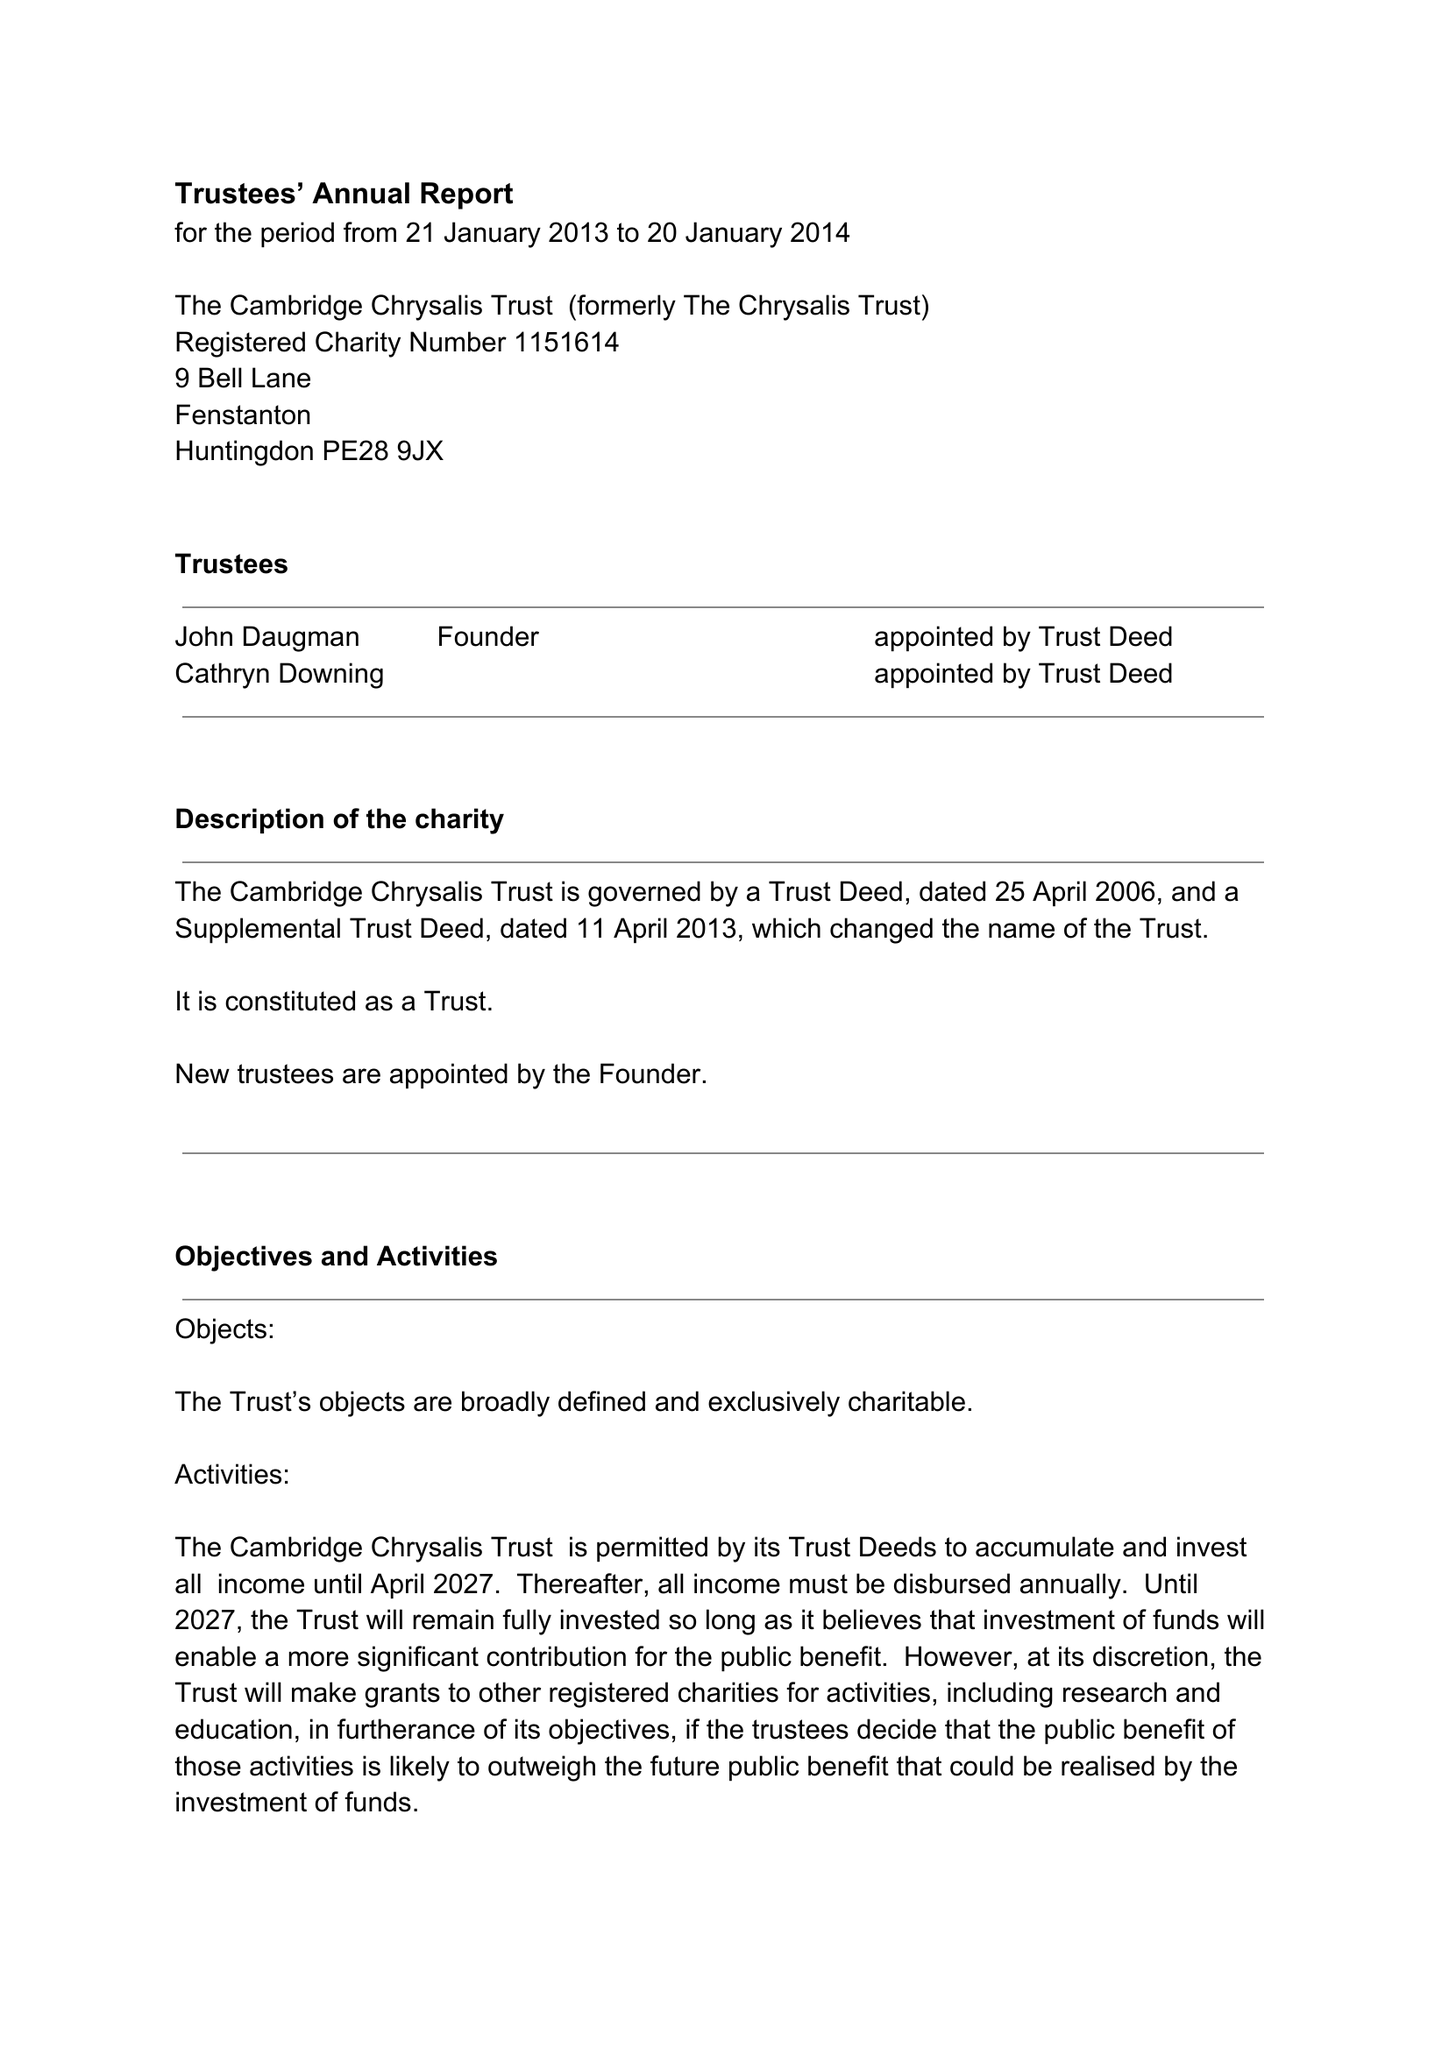What is the value for the income_annually_in_british_pounds?
Answer the question using a single word or phrase. 121451.00 